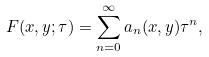<formula> <loc_0><loc_0><loc_500><loc_500>F ( x , y ; \tau ) = \sum _ { n = 0 } ^ { \infty } a _ { n } ( x , y ) \tau ^ { n } ,</formula> 